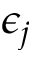<formula> <loc_0><loc_0><loc_500><loc_500>\epsilon _ { j }</formula> 